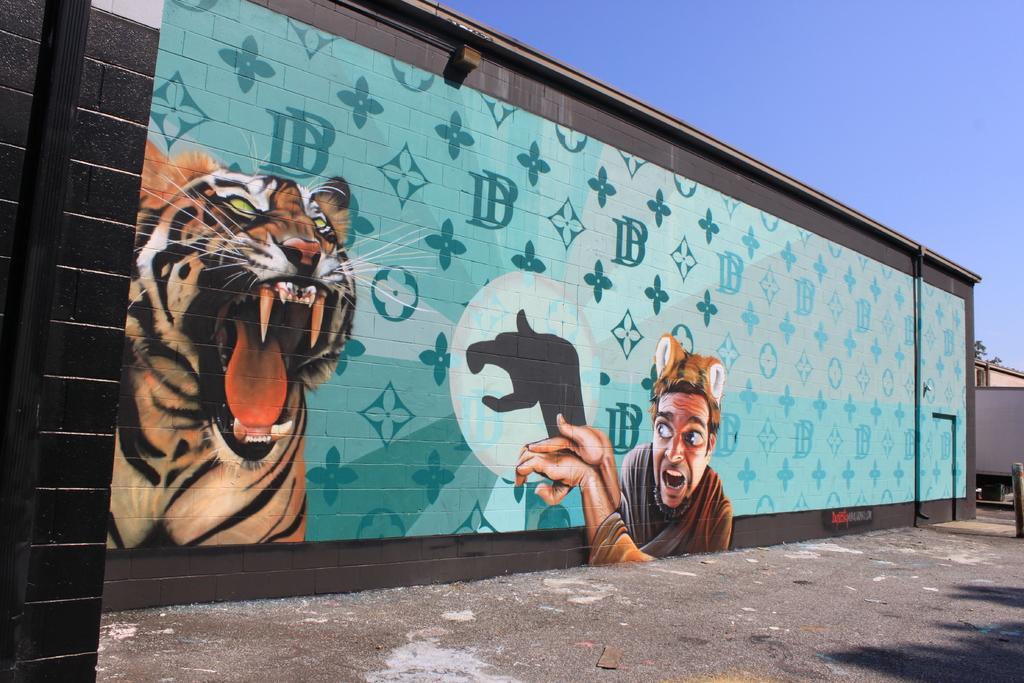Can you describe this image briefly? In this picture we can see the road, wall with a painting of a man and a tiger on it, pipes and in the background we can see the sky. 